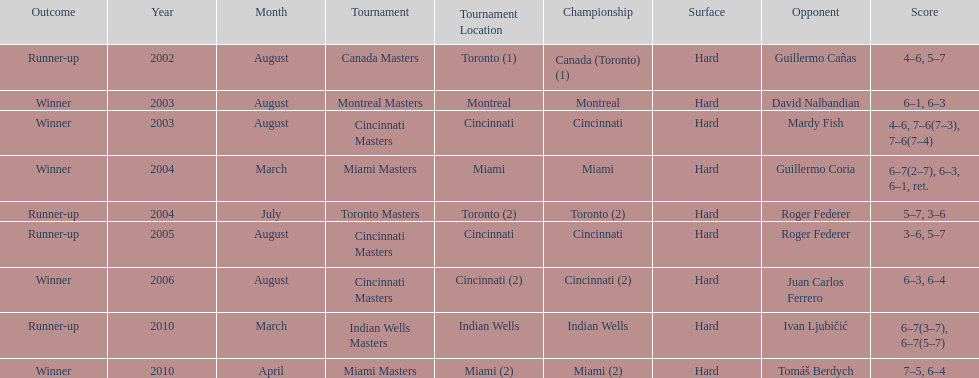Parse the full table. {'header': ['Outcome', 'Year', 'Month', 'Tournament', 'Tournament Location', 'Championship', 'Surface', 'Opponent', 'Score'], 'rows': [['Runner-up', '2002', 'August', 'Canada Masters', 'Toronto (1)', 'Canada (Toronto) (1)', 'Hard', 'Guillermo Cañas', '4–6, 5–7'], ['Winner', '2003', 'August', 'Montreal Masters', 'Montreal', 'Montreal', 'Hard', 'David Nalbandian', '6–1, 6–3'], ['Winner', '2003', 'August', 'Cincinnati Masters', 'Cincinnati', 'Cincinnati', 'Hard', 'Mardy Fish', '4–6, 7–6(7–3), 7–6(7–4)'], ['Winner', '2004', 'March', 'Miami Masters', 'Miami', 'Miami', 'Hard', 'Guillermo Coria', '6–7(2–7), 6–3, 6–1, ret.'], ['Runner-up', '2004', 'July', 'Toronto Masters', 'Toronto (2)', 'Toronto (2)', 'Hard', 'Roger Federer', '5–7, 3–6'], ['Runner-up', '2005', 'August', 'Cincinnati Masters', 'Cincinnati', 'Cincinnati', 'Hard', 'Roger Federer', '3–6, 5–7'], ['Winner', '2006', 'August', 'Cincinnati Masters', 'Cincinnati (2)', 'Cincinnati (2)', 'Hard', 'Juan Carlos Ferrero', '6–3, 6–4'], ['Runner-up', '2010', 'March', 'Indian Wells Masters', 'Indian Wells', 'Indian Wells', 'Hard', 'Ivan Ljubičić', '6–7(3–7), 6–7(5–7)'], ['Winner', '2010', 'April', 'Miami Masters', 'Miami (2)', 'Miami (2)', 'Hard', 'Tomáš Berdych', '7–5, 6–4']]} How many times was the championship in miami? 2. 